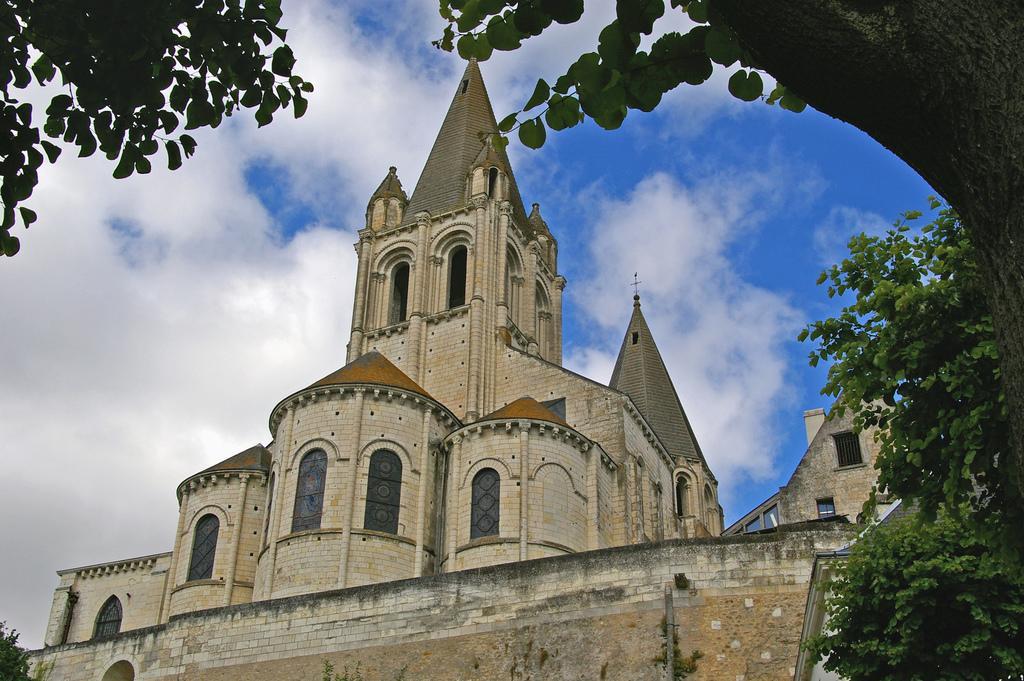Please provide a concise description of this image. In this image we can see the building and windows. And we can see the trees, at the top we can see the sky. 